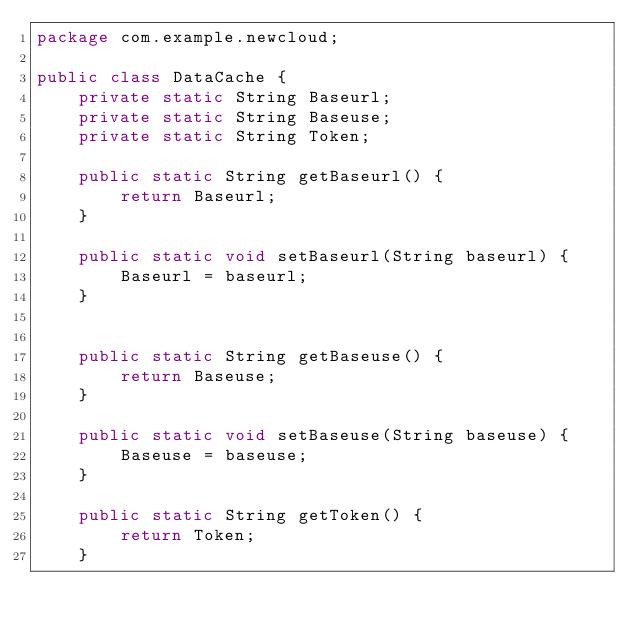<code> <loc_0><loc_0><loc_500><loc_500><_Java_>package com.example.newcloud;

public class DataCache {
    private static String Baseurl;
    private static String Baseuse;
    private static String Token;

    public static String getBaseurl() {
        return Baseurl;
    }

    public static void setBaseurl(String baseurl) {
        Baseurl = baseurl;
    }


    public static String getBaseuse() {
        return Baseuse;
    }

    public static void setBaseuse(String baseuse) {
        Baseuse = baseuse;
    }

    public static String getToken() {
        return Token;
    }
</code> 